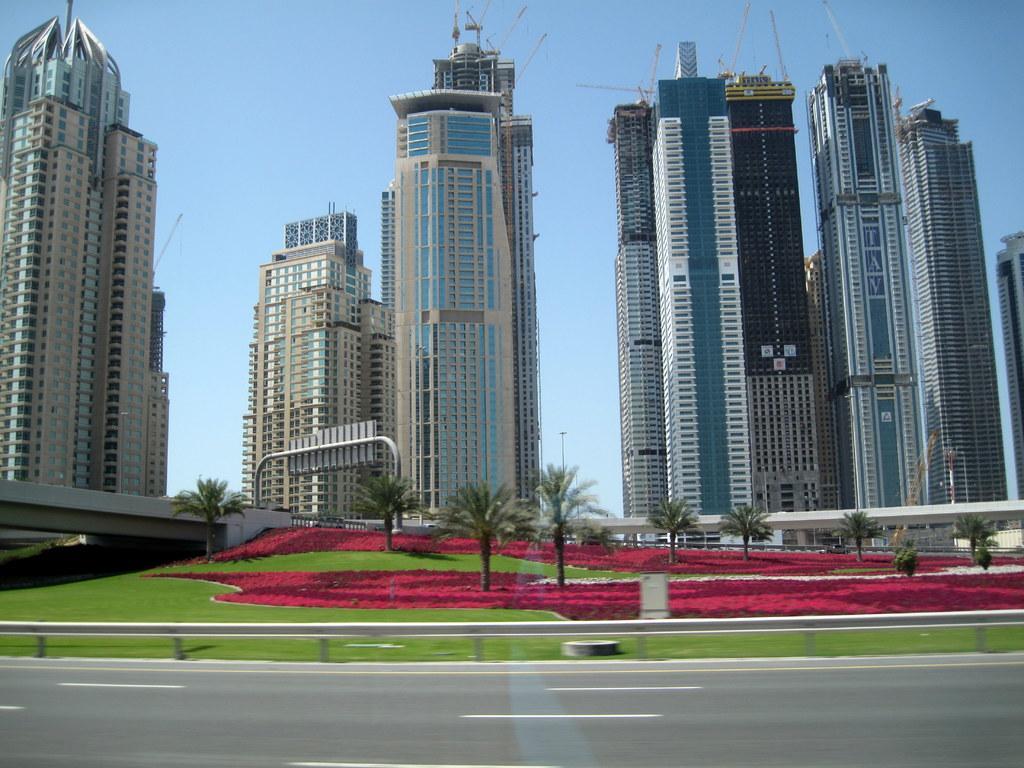Please provide a concise description of this image. This image consists of buildings. At the bottom, we can see green grass and small plants in red color. And we can see a road. At the top, there is sky. 